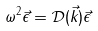<formula> <loc_0><loc_0><loc_500><loc_500>\omega ^ { 2 } \vec { \epsilon } = \mathcal { D } ( \vec { k } ) \vec { \epsilon }</formula> 